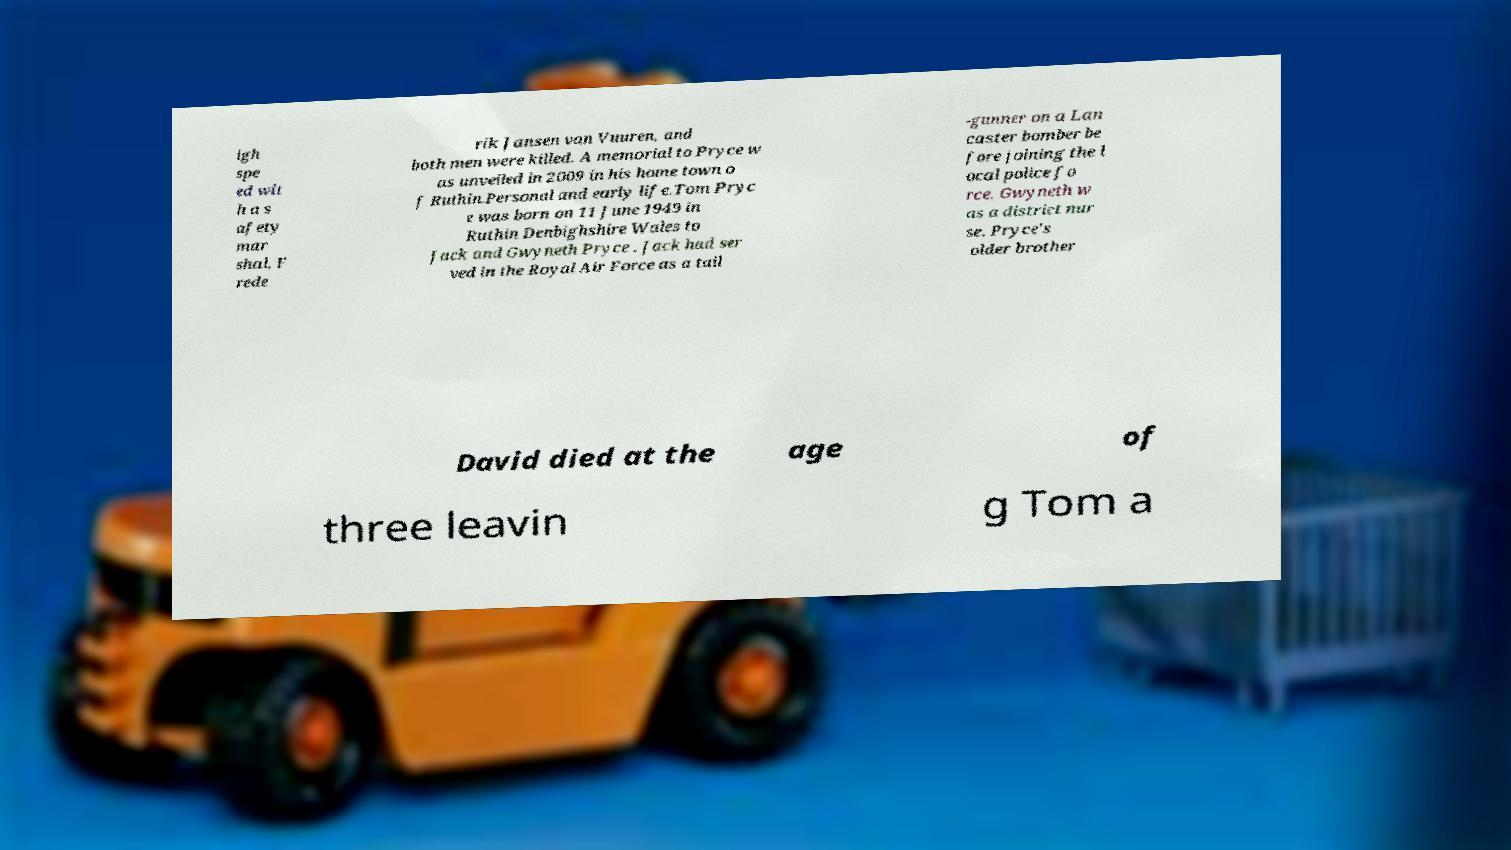Could you assist in decoding the text presented in this image and type it out clearly? igh spe ed wit h a s afety mar shal, F rede rik Jansen van Vuuren, and both men were killed. A memorial to Pryce w as unveiled in 2009 in his home town o f Ruthin.Personal and early life.Tom Pryc e was born on 11 June 1949 in Ruthin Denbighshire Wales to Jack and Gwyneth Pryce . Jack had ser ved in the Royal Air Force as a tail -gunner on a Lan caster bomber be fore joining the l ocal police fo rce. Gwyneth w as a district nur se. Pryce's older brother David died at the age of three leavin g Tom a 